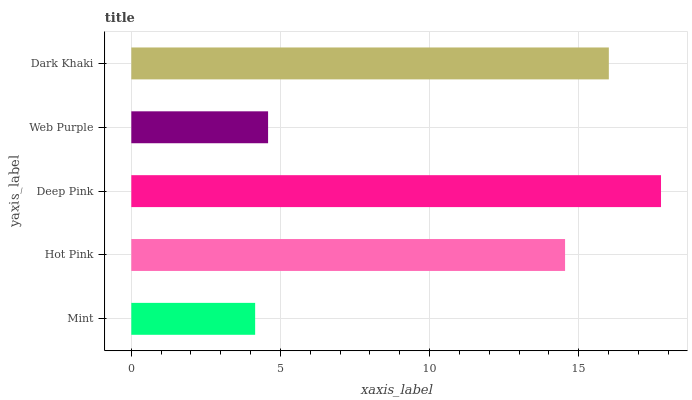Is Mint the minimum?
Answer yes or no. Yes. Is Deep Pink the maximum?
Answer yes or no. Yes. Is Hot Pink the minimum?
Answer yes or no. No. Is Hot Pink the maximum?
Answer yes or no. No. Is Hot Pink greater than Mint?
Answer yes or no. Yes. Is Mint less than Hot Pink?
Answer yes or no. Yes. Is Mint greater than Hot Pink?
Answer yes or no. No. Is Hot Pink less than Mint?
Answer yes or no. No. Is Hot Pink the high median?
Answer yes or no. Yes. Is Hot Pink the low median?
Answer yes or no. Yes. Is Deep Pink the high median?
Answer yes or no. No. Is Web Purple the low median?
Answer yes or no. No. 